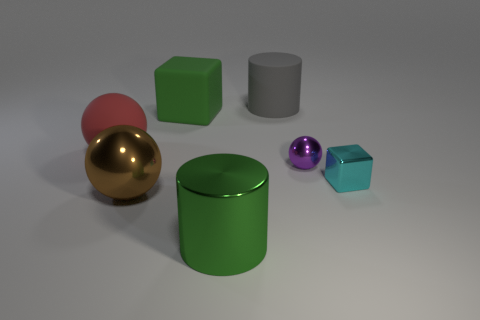There is a large cylinder that is in front of the large cylinder behind the tiny block; are there any large red rubber things that are right of it?
Keep it short and to the point. No. There is a object that is both to the left of the big gray rubber cylinder and behind the rubber ball; how big is it?
Your response must be concise. Large. How many small cyan cubes have the same material as the big block?
Make the answer very short. 0. What number of balls are either brown shiny objects or purple shiny objects?
Your answer should be very brief. 2. How big is the sphere to the right of the big cylinder behind the large metallic object on the left side of the big block?
Ensure brevity in your answer.  Small. What color is the ball that is in front of the red thing and behind the small cyan object?
Offer a terse response. Purple. There is a purple object; does it have the same size as the brown metallic object that is on the right side of the red sphere?
Your response must be concise. No. Is there any other thing that has the same shape as the tiny purple metallic object?
Your answer should be very brief. Yes. The matte object that is the same shape as the purple metallic object is what color?
Your response must be concise. Red. Does the gray cylinder have the same size as the red rubber thing?
Offer a very short reply. Yes. 